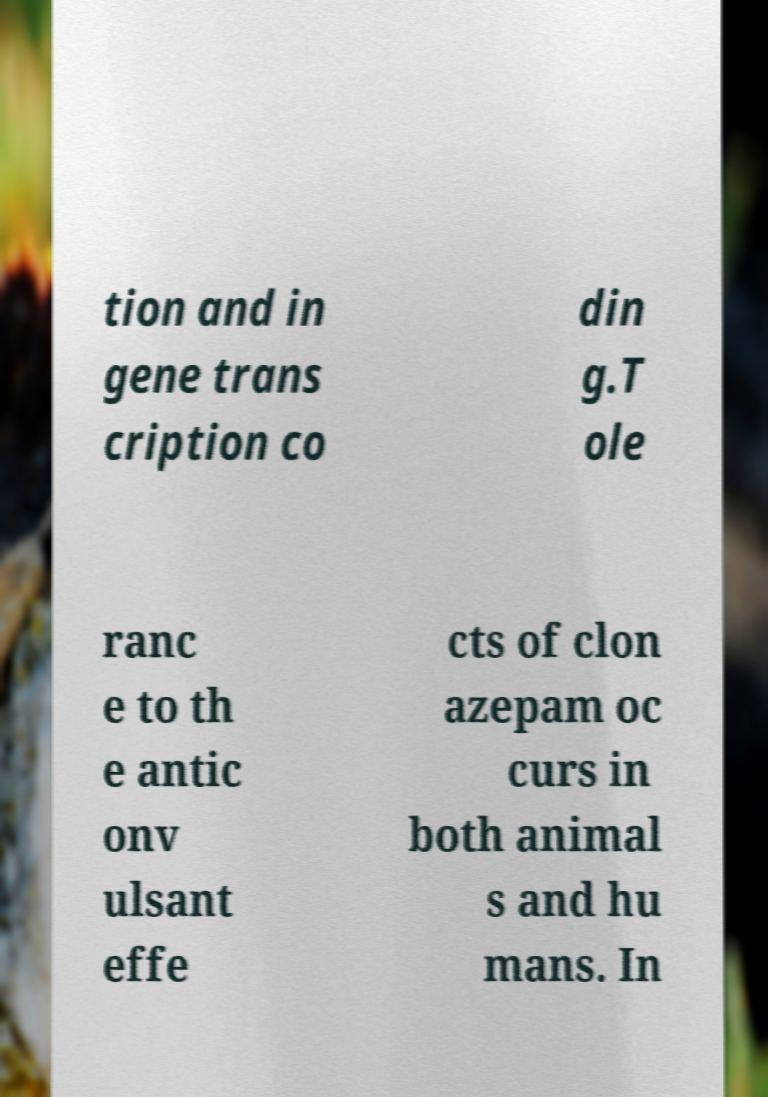Please identify and transcribe the text found in this image. tion and in gene trans cription co din g.T ole ranc e to th e antic onv ulsant effe cts of clon azepam oc curs in both animal s and hu mans. In 